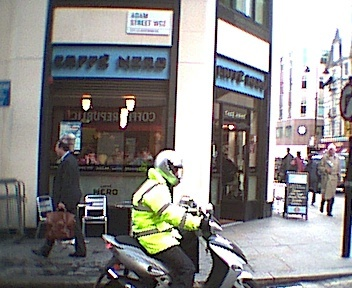Describe the objects in this image and their specific colors. I can see motorcycle in gray, black, white, and darkgray tones, people in gray, ivory, black, khaki, and yellow tones, people in gray, black, and maroon tones, people in gray and darkgray tones, and suitcase in gray, black, maroon, and brown tones in this image. 